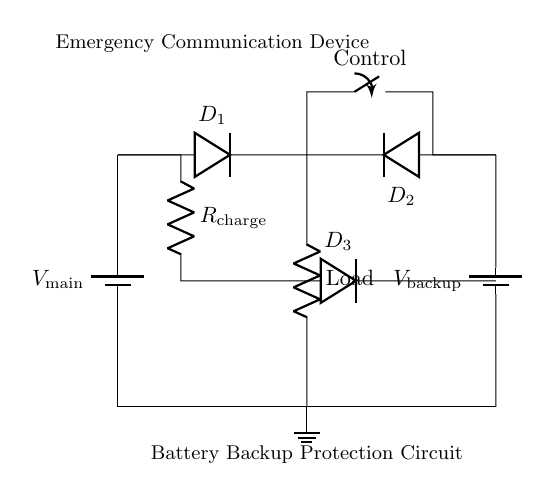What is the main power supply voltage? The main power supply is labeled as V_main, but the exact voltage value is not specified in the circuit diagram. Therefore, we cannot ascertain a specific number.
Answer: Unknown What component is used to prevent backflow of current? The circuit uses two diodes, D_1 and D_2, which are positioned at the outputs of both the main power supply and backup battery. Their function is to prevent current from flowing back into the power sources, ensuring proper functioning of the loads.
Answer: Diodes What is the load in this circuit? The load is represented simply as "Load" in the diagram, indicating that it is a resistive component but it does not specify the exact resistance value.
Answer: Load How many batteries are in the circuit? The circuit includes two batteries: one labeled as the main power supply and the other as the backup battery. This configuration provides redundancy in case the main power fails.
Answer: Two batteries What component controls the switching between power sources? The control of switching is handled by a switch labeled as "Control." This SPST switch enables selection between the primary and backup power sources, ensuring that communication devices remain powered during emergencies.
Answer: Control switch How does the backup battery get charged? The charging mechanism is established via the resistor labeled R_charge and the diode D_3. When the main power supply is functional, it provides voltage through R_charge to charge the backup battery, while the diode ensures that the current does not backflow into the main power source.
Answer: Resistor and diode 